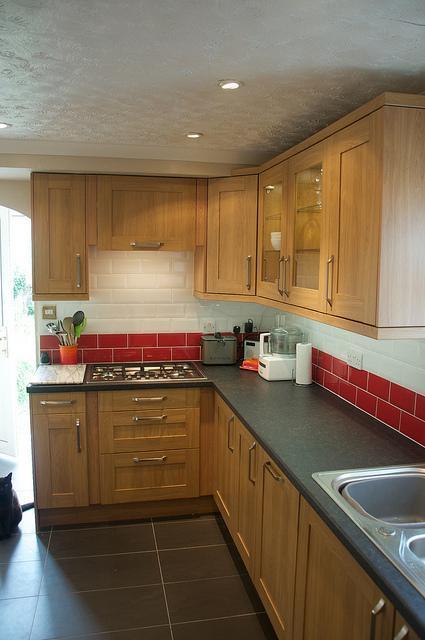How many sinks are there?
Give a very brief answer. 1. 